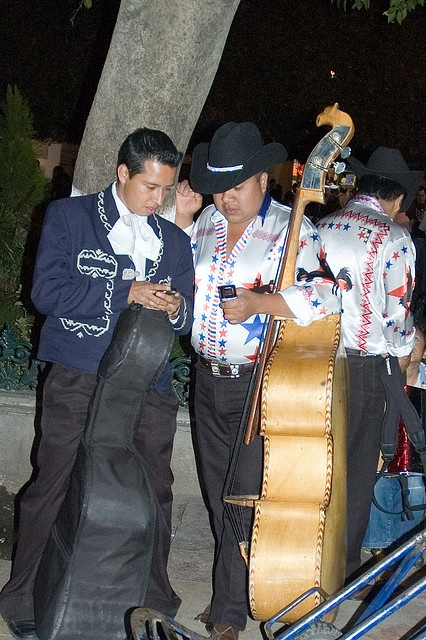Describe the objects in this image and their specific colors. I can see people in black, navy, darkblue, and gray tones, people in black, white, and gray tones, people in black, lightgray, and gray tones, people in black and gray tones, and cell phone in black, gray, navy, and white tones in this image. 